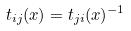Convert formula to latex. <formula><loc_0><loc_0><loc_500><loc_500>t _ { i j } ( x ) = t _ { j i } ( x ) ^ { - 1 }</formula> 